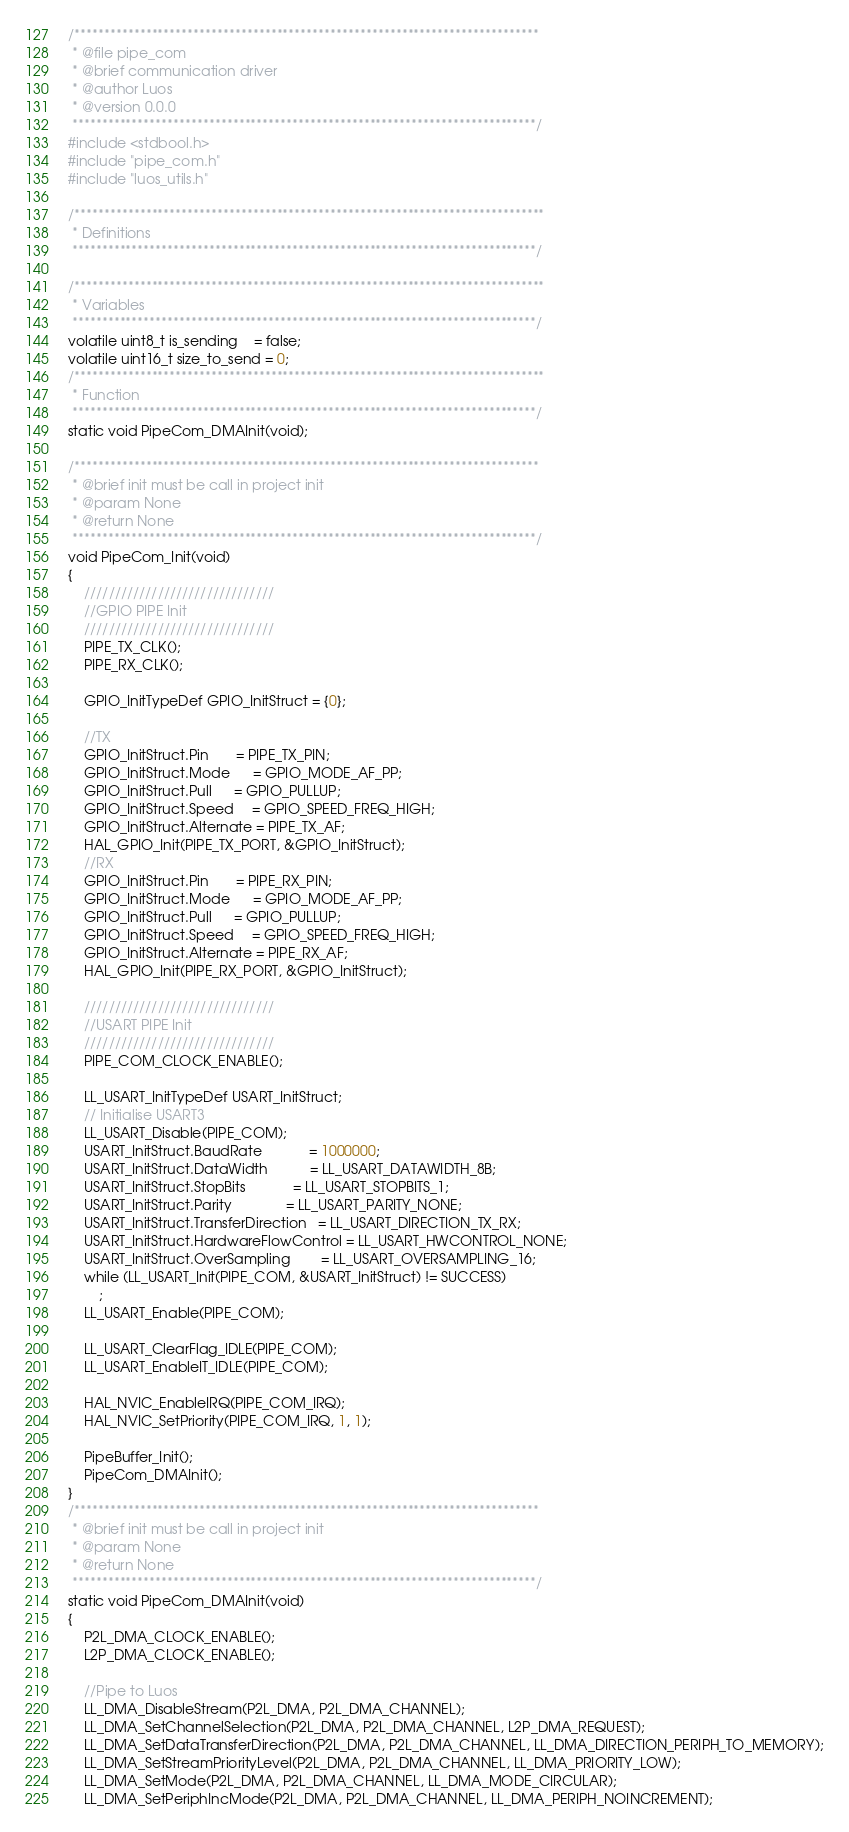Convert code to text. <code><loc_0><loc_0><loc_500><loc_500><_C_>/******************************************************************************
 * @file pipe_com
 * @brief communication driver
 * @author Luos
 * @version 0.0.0
 ******************************************************************************/
#include <stdbool.h>
#include "pipe_com.h"
#include "luos_utils.h"

/*******************************************************************************
 * Definitions
 ******************************************************************************/

/*******************************************************************************
 * Variables
 ******************************************************************************/
volatile uint8_t is_sending    = false;
volatile uint16_t size_to_send = 0;
/*******************************************************************************
 * Function
 ******************************************************************************/
static void PipeCom_DMAInit(void);

/******************************************************************************
 * @brief init must be call in project init
 * @param None
 * @return None
 ******************************************************************************/
void PipeCom_Init(void)
{
    ///////////////////////////////
    //GPIO PIPE Init
    ///////////////////////////////
    PIPE_TX_CLK();
    PIPE_RX_CLK();

    GPIO_InitTypeDef GPIO_InitStruct = {0};

    //TX
    GPIO_InitStruct.Pin       = PIPE_TX_PIN;
    GPIO_InitStruct.Mode      = GPIO_MODE_AF_PP;
    GPIO_InitStruct.Pull      = GPIO_PULLUP;
    GPIO_InitStruct.Speed     = GPIO_SPEED_FREQ_HIGH;
    GPIO_InitStruct.Alternate = PIPE_TX_AF;
    HAL_GPIO_Init(PIPE_TX_PORT, &GPIO_InitStruct);
    //RX
    GPIO_InitStruct.Pin       = PIPE_RX_PIN;
    GPIO_InitStruct.Mode      = GPIO_MODE_AF_PP;
    GPIO_InitStruct.Pull      = GPIO_PULLUP;
    GPIO_InitStruct.Speed     = GPIO_SPEED_FREQ_HIGH;
    GPIO_InitStruct.Alternate = PIPE_RX_AF;
    HAL_GPIO_Init(PIPE_RX_PORT, &GPIO_InitStruct);

    ///////////////////////////////
    //USART PIPE Init
    ///////////////////////////////
    PIPE_COM_CLOCK_ENABLE();

    LL_USART_InitTypeDef USART_InitStruct;
    // Initialise USART3
    LL_USART_Disable(PIPE_COM);
    USART_InitStruct.BaudRate            = 1000000;
    USART_InitStruct.DataWidth           = LL_USART_DATAWIDTH_8B;
    USART_InitStruct.StopBits            = LL_USART_STOPBITS_1;
    USART_InitStruct.Parity              = LL_USART_PARITY_NONE;
    USART_InitStruct.TransferDirection   = LL_USART_DIRECTION_TX_RX;
    USART_InitStruct.HardwareFlowControl = LL_USART_HWCONTROL_NONE;
    USART_InitStruct.OverSampling        = LL_USART_OVERSAMPLING_16;
    while (LL_USART_Init(PIPE_COM, &USART_InitStruct) != SUCCESS)
        ;
    LL_USART_Enable(PIPE_COM);

    LL_USART_ClearFlag_IDLE(PIPE_COM);
    LL_USART_EnableIT_IDLE(PIPE_COM);

    HAL_NVIC_EnableIRQ(PIPE_COM_IRQ);
    HAL_NVIC_SetPriority(PIPE_COM_IRQ, 1, 1);

    PipeBuffer_Init();
    PipeCom_DMAInit();
}
/******************************************************************************
 * @brief init must be call in project init
 * @param None
 * @return None
 ******************************************************************************/
static void PipeCom_DMAInit(void)
{
    P2L_DMA_CLOCK_ENABLE();
    L2P_DMA_CLOCK_ENABLE();

    //Pipe to Luos
    LL_DMA_DisableStream(P2L_DMA, P2L_DMA_CHANNEL);
    LL_DMA_SetChannelSelection(P2L_DMA, P2L_DMA_CHANNEL, L2P_DMA_REQUEST);
    LL_DMA_SetDataTransferDirection(P2L_DMA, P2L_DMA_CHANNEL, LL_DMA_DIRECTION_PERIPH_TO_MEMORY);
    LL_DMA_SetStreamPriorityLevel(P2L_DMA, P2L_DMA_CHANNEL, LL_DMA_PRIORITY_LOW);
    LL_DMA_SetMode(P2L_DMA, P2L_DMA_CHANNEL, LL_DMA_MODE_CIRCULAR);
    LL_DMA_SetPeriphIncMode(P2L_DMA, P2L_DMA_CHANNEL, LL_DMA_PERIPH_NOINCREMENT);</code> 